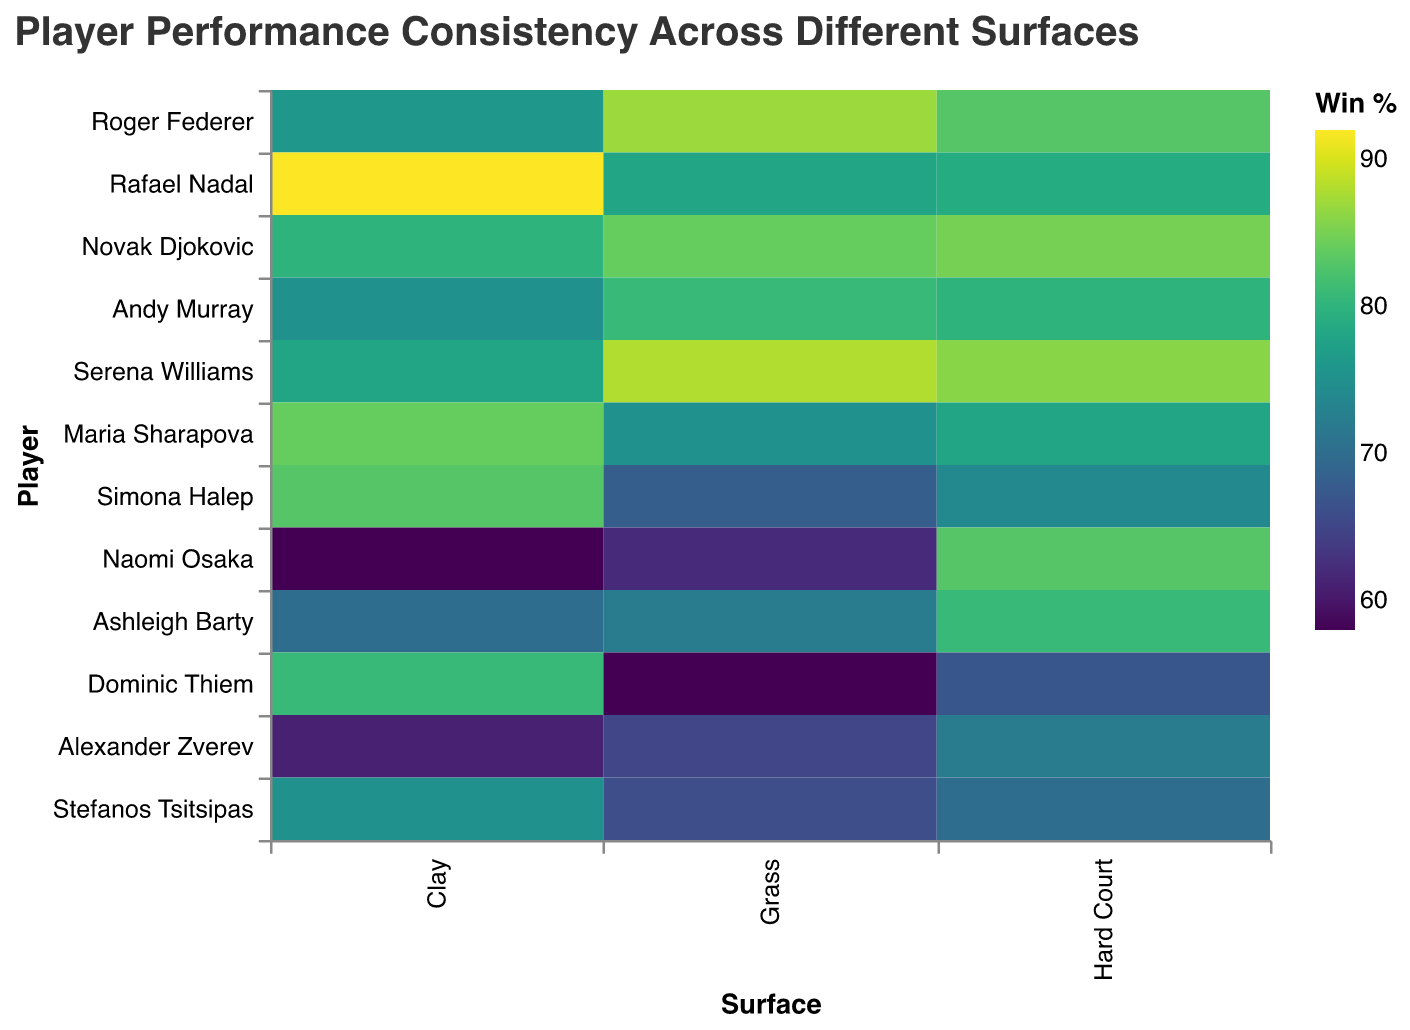What is the title of the heatmap? The title is generally located at the top of the heatmap, presenting a summary of the data being visualized.
Answer: Player Performance Consistency Across Different Surfaces Which player has the highest win percentage on Grass? By looking at the color gradient corresponding to Grass on the leftmost column, the player with the darkest cell under Grass is Serena Williams with a win percentage of 88.
Answer: Serena Williams Who has the lowest win percentage on Clay? Identify the lightest cell within the Clay column, which corresponds to Naomi Osaka with a win percentage of 58.
Answer: Naomi Osaka How does Roger Federer's win percentage compare across different surfaces? Look at the different cells in the row for Roger Federer. His win percentages on Grass, Clay, and Hard Court are 87, 76, and 83, respectively.
Answer: Grass: 87, Clay: 76, Hard Court: 83 Who is more consistent across all surfaces, Rafael Nadal or Novak Djokovic? Consistency can be judged by looking at how close the win percentages are across surfaces. Rafael Nadal's ranges are 78 (Grass), 92 (Clay), and 79 (Hard Court), whereas Novak Djokovic's ranges are 84 (Grass), 80 (Clay), and 85 (Hard Court). Djokovic has more consistent values.
Answer: Novak Djokovic What is the average win percentage for Simona Halep across all surfaces? Add her win percentages (68 for Grass, 83 for Clay, and 74 for Hard Court) and divide by 3. (68 + 83 + 74) / 3 = 225 / 3 = 75
Answer: 75 Which surface does Andy Murray perform better on average compared to Maria Sharapova? Compare the win percentages for both players on each surface. Andy Murray: Grass (81), Clay (75), Hard (80); Maria Sharapova: Grass (75), Clay (84), Hard (78). Andy Murray performs better on Grass and Hard Court, while Sharapova is better on Clay.
Answer: Grass, Hard Court Is there any player who has the same win percentage on at least one surface? Check for identical values across different rows and columns. It can be seen that Serena Williams and Naomi Osaka both have a win percentage of 86 and 83 on Hard Court, respectively.
Answer: Yes, Serena Williams and Naomi Osaka Which player shows the most significant drop in performance from Grass to Clay? Calculate the difference between Grass and Clay win percentages for each player and identify the largest drop. Naomi Osaka has the most considerable drop from 62 (Grass) to 58 (Clay), but Dominic Thiem's drop from 58 (Grass) to 81 (Clay) is more significant.
Answer: Dominic Thiem Who has the highest win rate on Clay, and what is it? Look at the darkest cell within the Clay column; Rafael Nadal stands out with a win percentage of 92.
Answer: Rafael Nadal, 92 